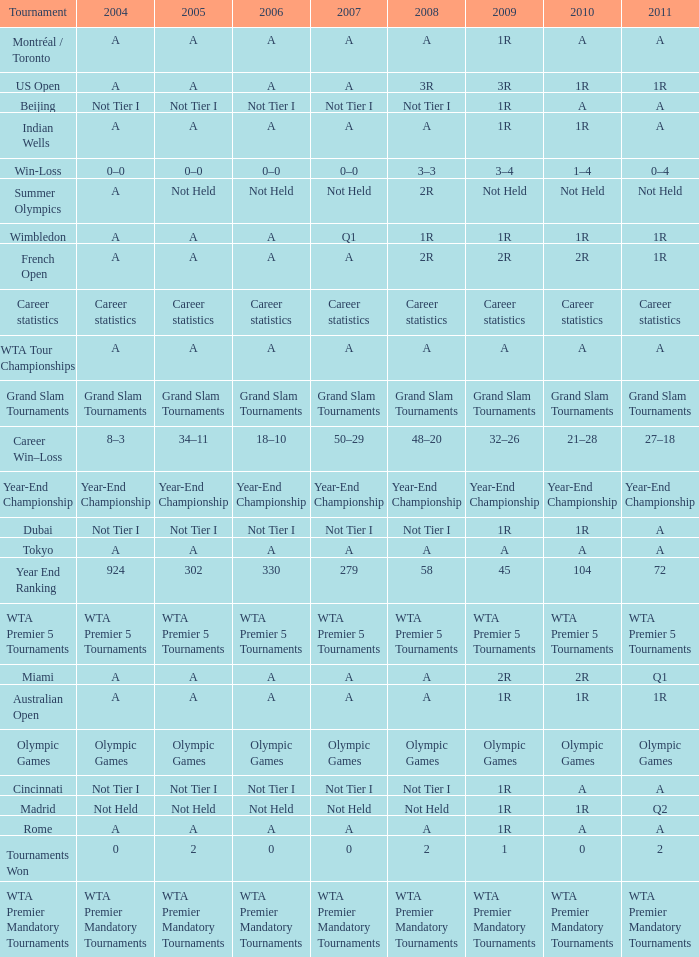What is 2011, when 2010 is "WTA Premier 5 Tournaments"? WTA Premier 5 Tournaments. 